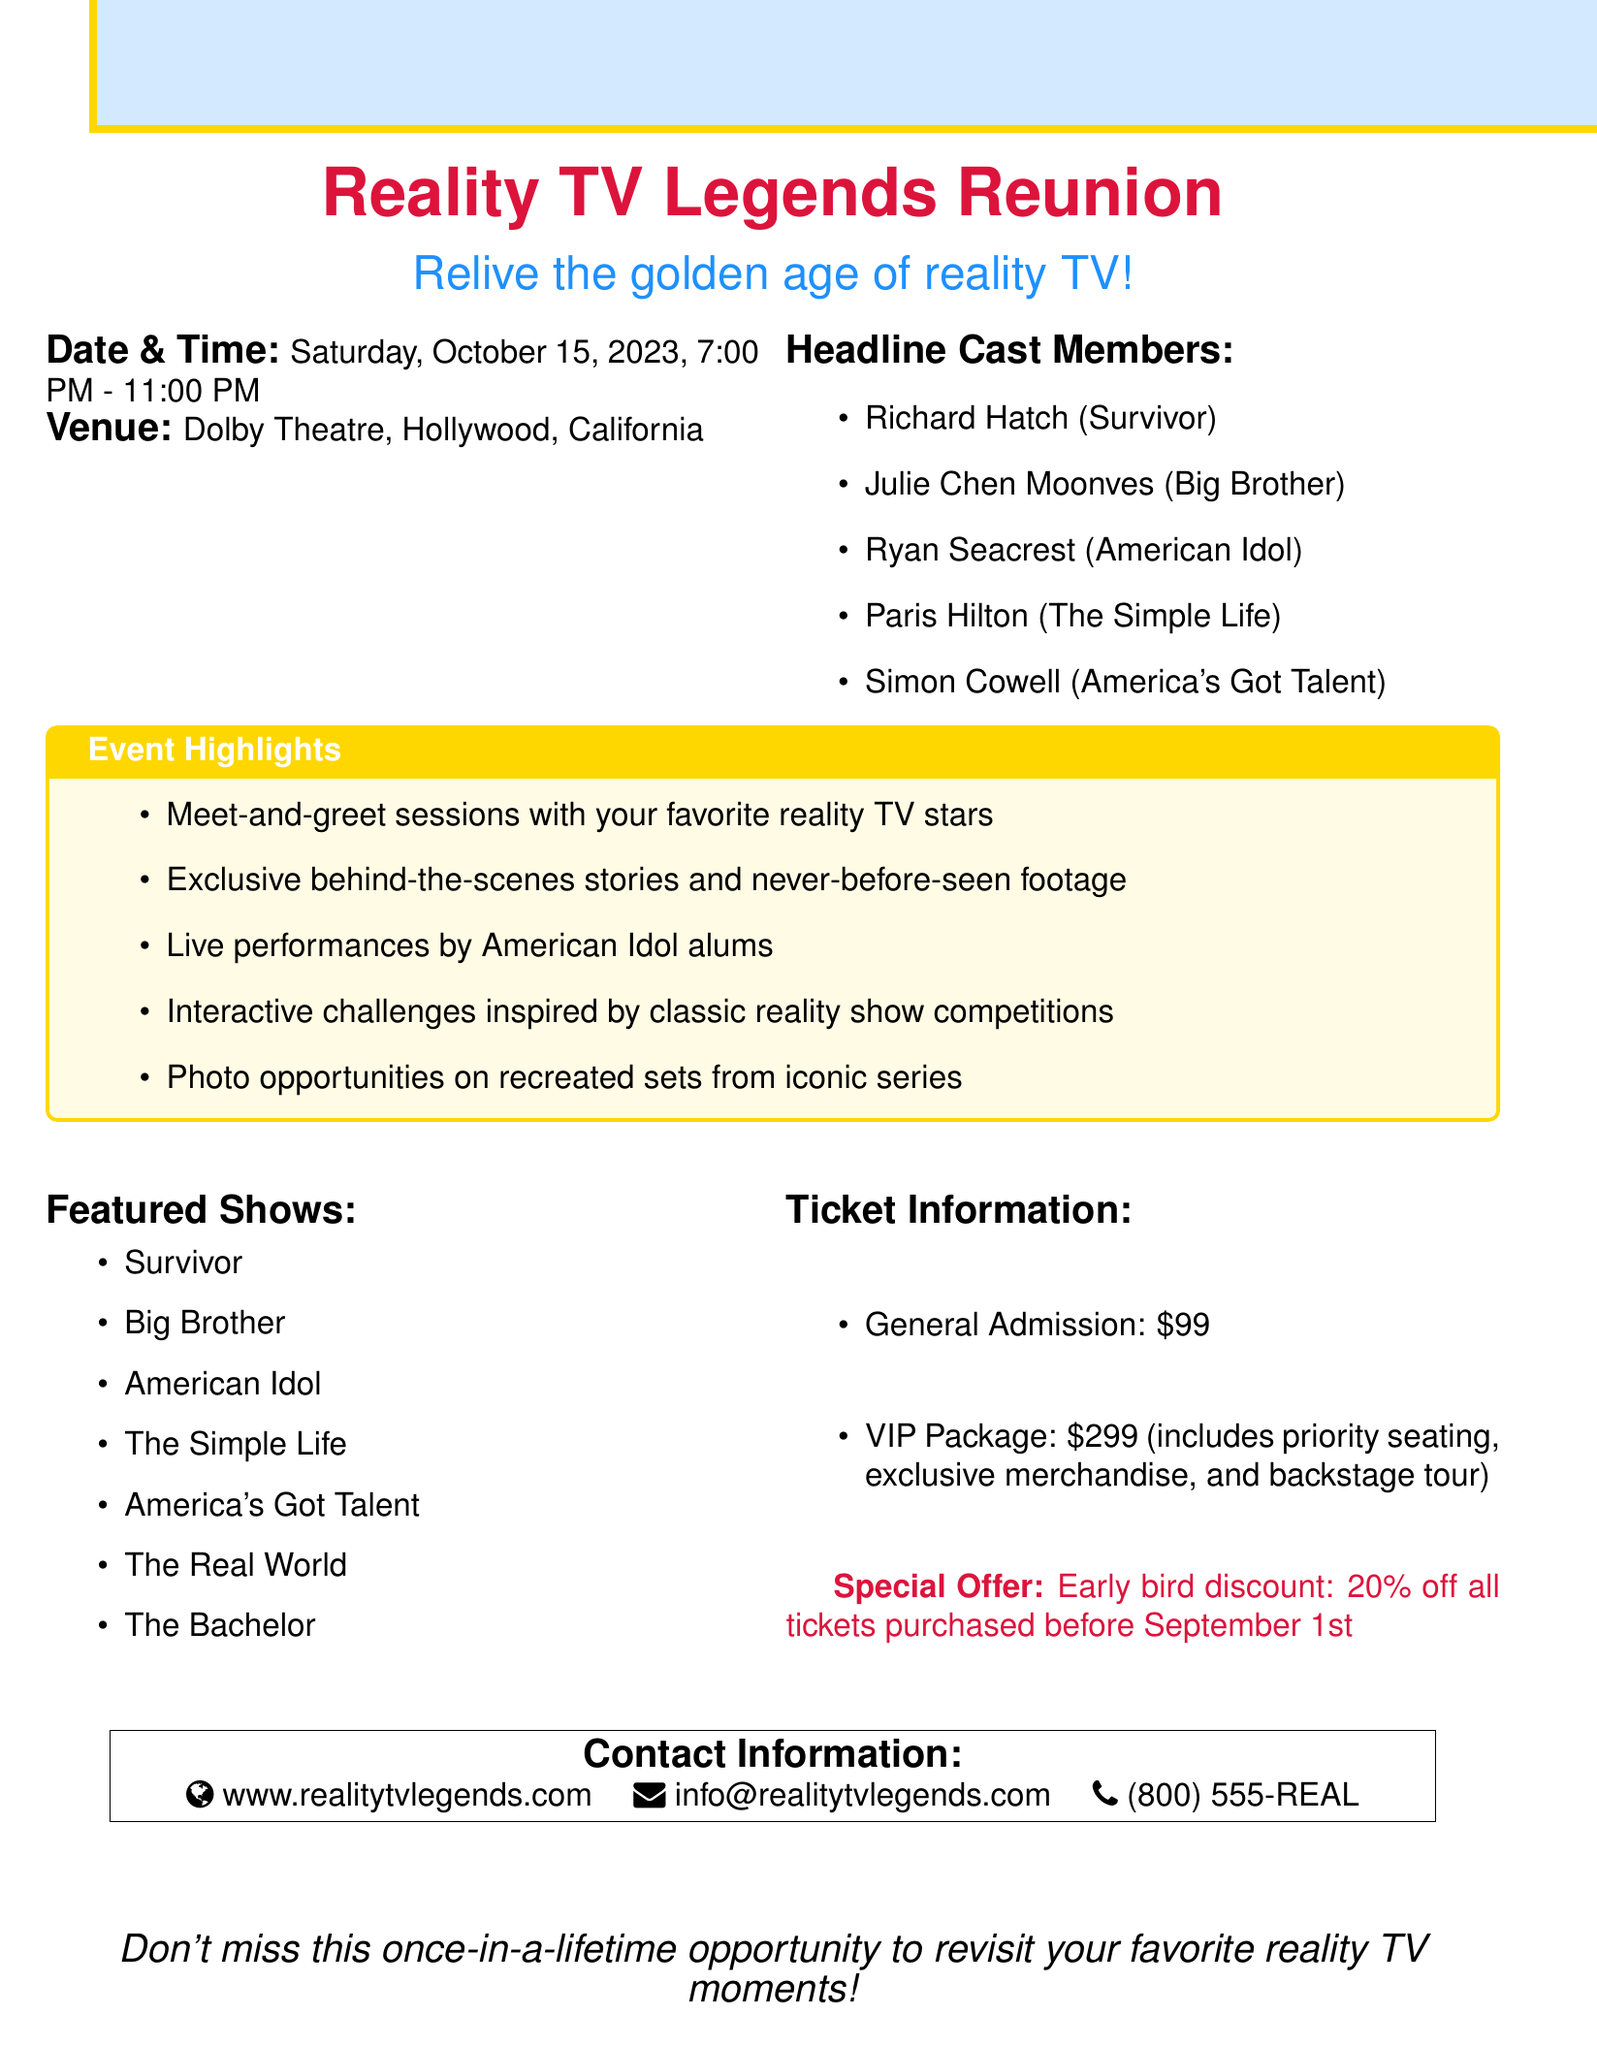What is the event name? The event name is stated prominently at the top of the document.
Answer: Reality TV Legends Reunion When is the event scheduled to take place? The date and time of the event are provided in the document.
Answer: Saturday, October 15, 2023, 7:00 PM - 11:00 PM Where is the event venue? The venue for the event is clearly mentioned in the document.
Answer: Dolby Theatre, Hollywood, California Who is one of the headline cast members? The document lists several headline cast members in a bullet-point format.
Answer: Richard Hatch (Survivor) What is the price of the VIP package? The ticket information section outlines the price for the VIP package.
Answer: $299 What discount is offered for early bird ticket purchases? The special offer section specifies the early bird discount available.
Answer: 20% off How many featured shows are listed in the document? The featured shows are presented in a bullet list, which can be counted.
Answer: 7 What type of performances will be present at the event? The event highlights section mentions the type of performances expected.
Answer: Live performances by American Idol alums Is there an opportunity for photos at the event? The event highlights indicate photo opportunities as part of the experience.
Answer: Yes 